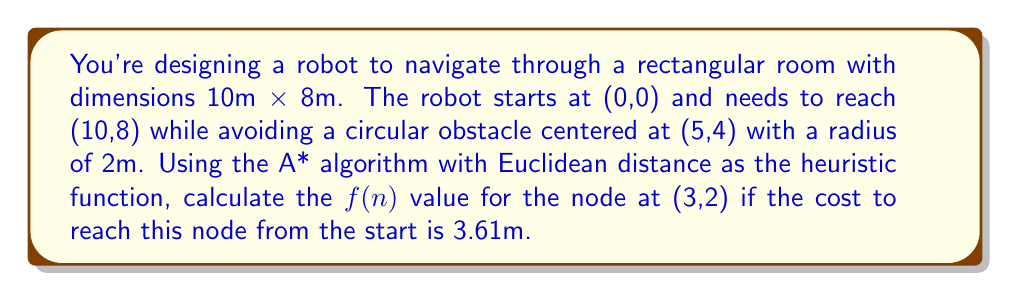Can you solve this math problem? To solve this problem using the A* algorithm, we need to calculate $f(n) = g(n) + h(n)$, where:
- $g(n)$ is the cost to reach the current node from the start
- $h(n)$ is the heuristic estimate of the cost from the current node to the goal

Step 1: Identify the given information
- Start point: (0,0)
- Goal point: (10,8)
- Current node: (3,2)
- $g(n) = 3.61$ (given)

Step 2: Calculate $h(n)$ using the Euclidean distance formula
$$h(n) = \sqrt{(x_2-x_1)^2 + (y_2-y_1)^2}$$
Where $(x_1,y_1)$ is the current node and $(x_2,y_2)$ is the goal node.

$$h(n) = \sqrt{(10-3)^2 + (8-2)^2}$$
$$h(n) = \sqrt{7^2 + 6^2}$$
$$h(n) = \sqrt{49 + 36}$$
$$h(n) = \sqrt{85}$$
$$h(n) \approx 9.22$$

Step 3: Calculate $f(n)$
$$f(n) = g(n) + h(n)$$
$$f(n) = 3.61 + 9.22$$
$$f(n) = 12.83$$

Therefore, the $f(n)$ value for the node at (3,2) is approximately 12.83.
Answer: $f(n) \approx 12.83$ 